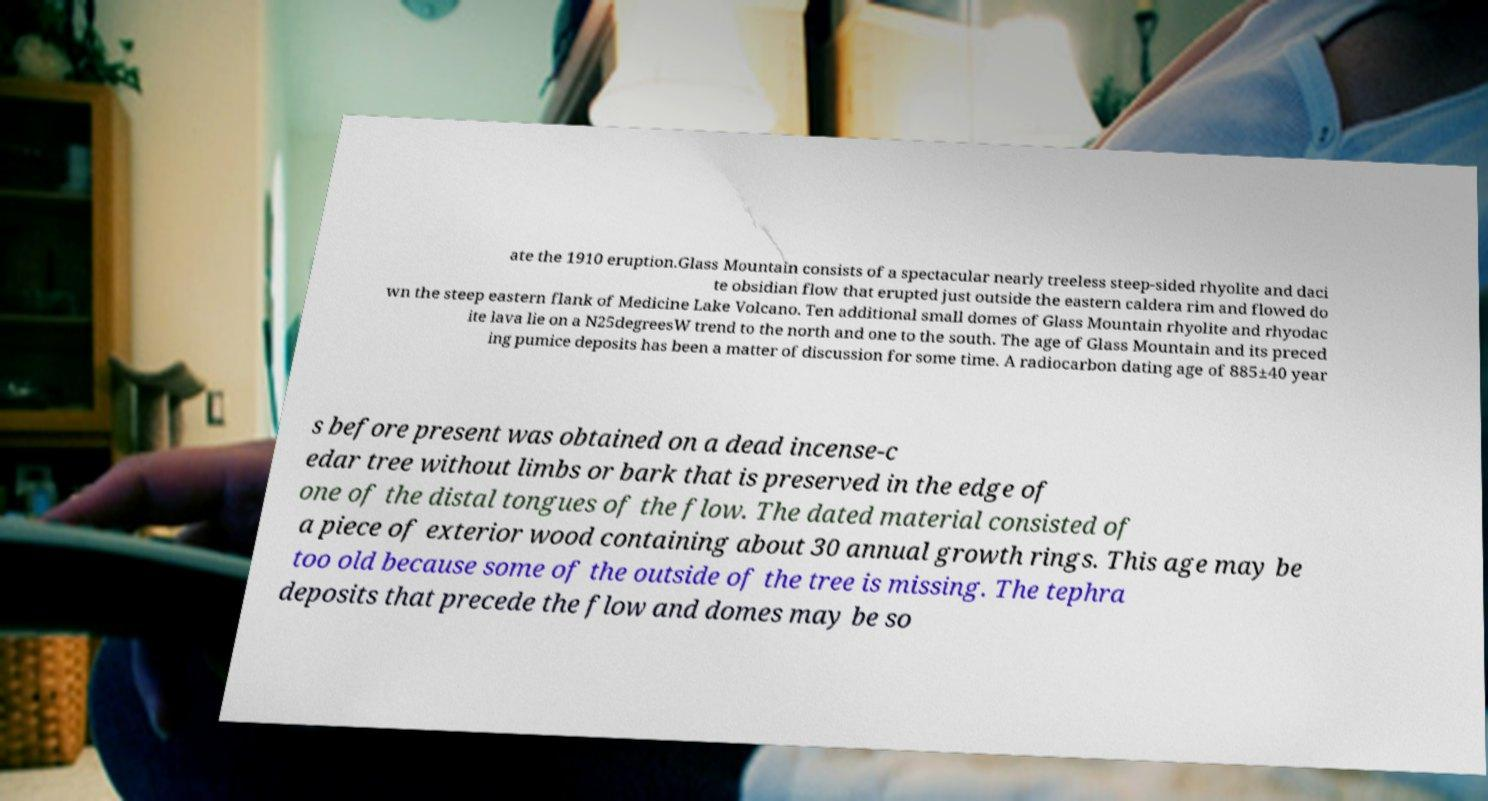Could you assist in decoding the text presented in this image and type it out clearly? ate the 1910 eruption.Glass Mountain consists of a spectacular nearly treeless steep-sided rhyolite and daci te obsidian flow that erupted just outside the eastern caldera rim and flowed do wn the steep eastern flank of Medicine Lake Volcano. Ten additional small domes of Glass Mountain rhyolite and rhyodac ite lava lie on a N25degreesW trend to the north and one to the south. The age of Glass Mountain and its preced ing pumice deposits has been a matter of discussion for some time. A radiocarbon dating age of 885±40 year s before present was obtained on a dead incense-c edar tree without limbs or bark that is preserved in the edge of one of the distal tongues of the flow. The dated material consisted of a piece of exterior wood containing about 30 annual growth rings. This age may be too old because some of the outside of the tree is missing. The tephra deposits that precede the flow and domes may be so 